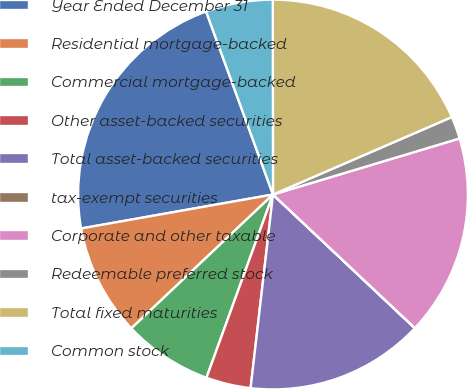Convert chart to OTSL. <chart><loc_0><loc_0><loc_500><loc_500><pie_chart><fcel>Year Ended December 31<fcel>Residential mortgage-backed<fcel>Commercial mortgage-backed<fcel>Other asset-backed securities<fcel>Total asset-backed securities<fcel>tax-exempt securities<fcel>Corporate and other taxable<fcel>Redeemable preferred stock<fcel>Total fixed maturities<fcel>Common stock<nl><fcel>22.21%<fcel>9.26%<fcel>7.41%<fcel>3.71%<fcel>14.81%<fcel>0.01%<fcel>16.66%<fcel>1.86%<fcel>18.51%<fcel>5.56%<nl></chart> 